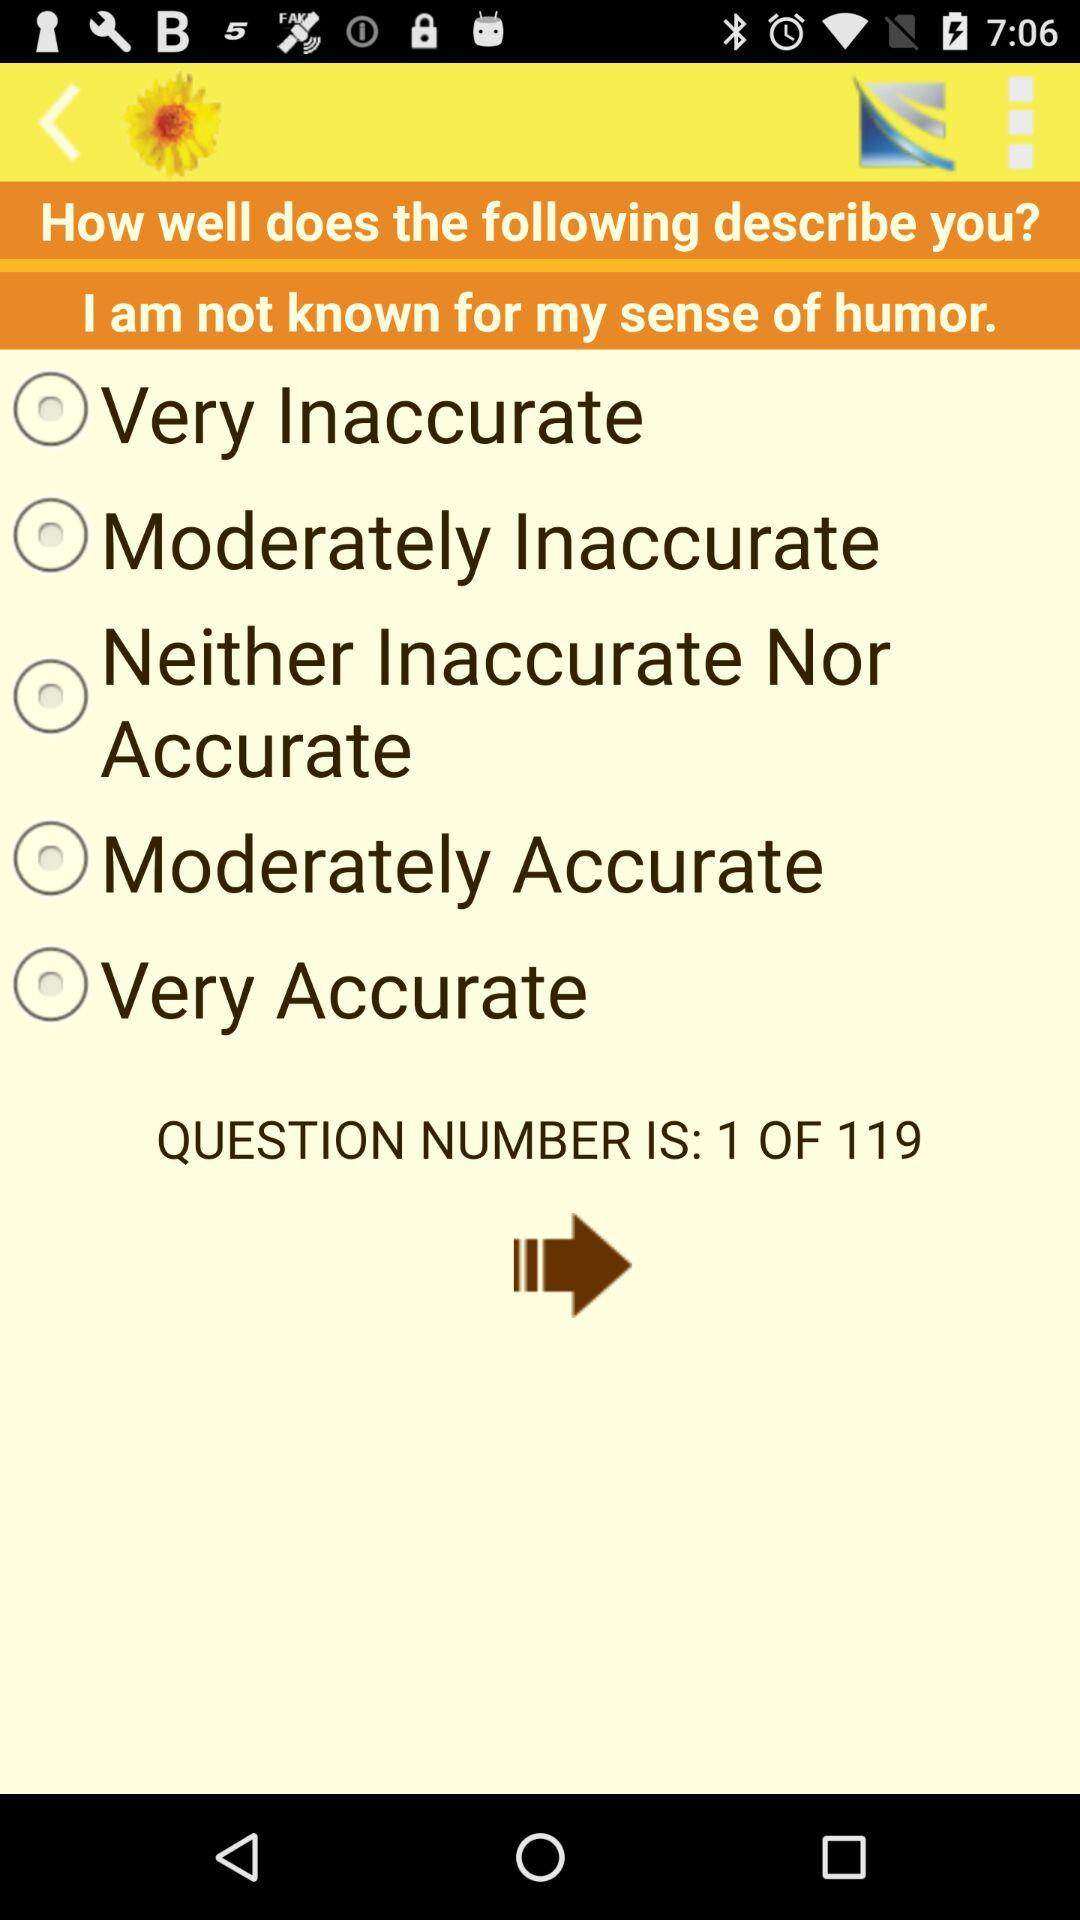How many questions in total are there? There are 119 questions. 